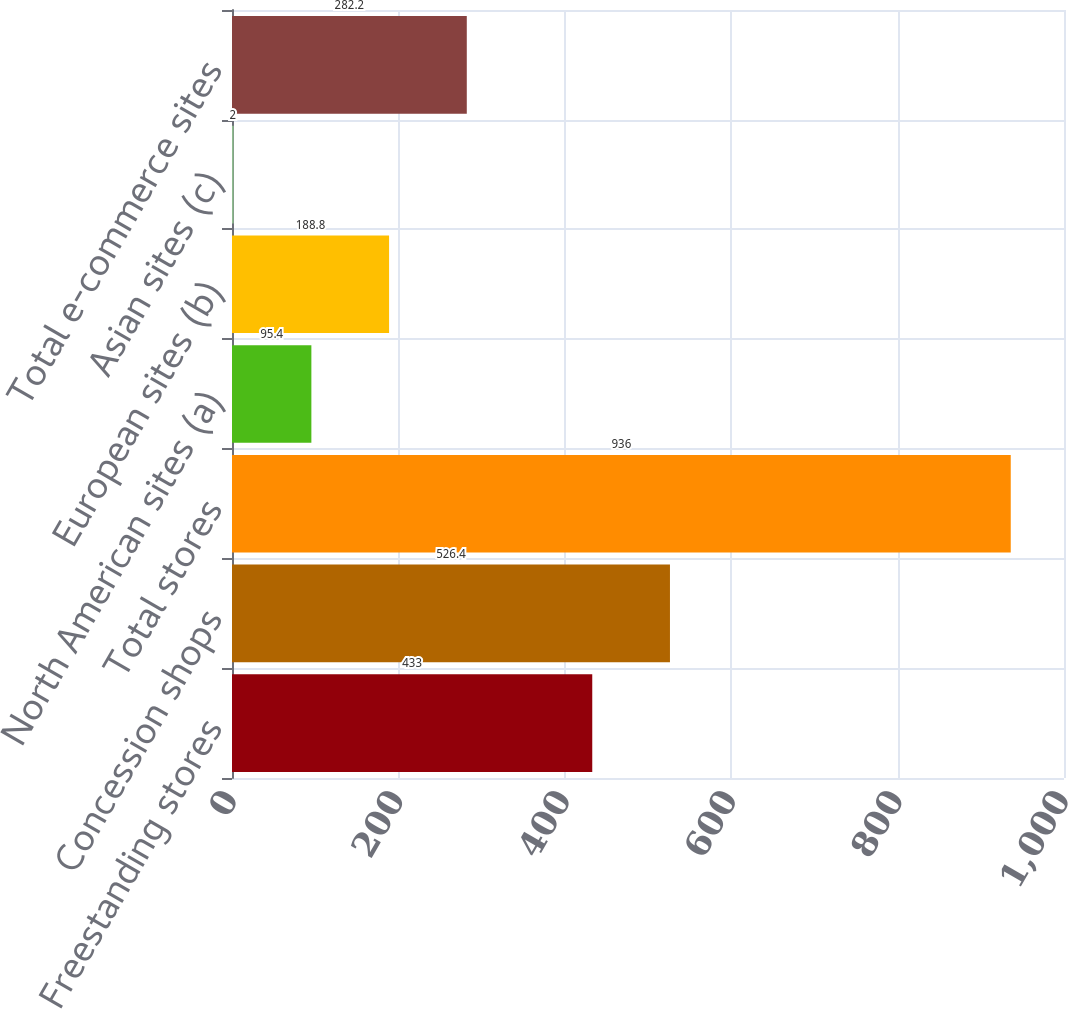Convert chart to OTSL. <chart><loc_0><loc_0><loc_500><loc_500><bar_chart><fcel>Freestanding stores<fcel>Concession shops<fcel>Total stores<fcel>North American sites (a)<fcel>European sites (b)<fcel>Asian sites (c)<fcel>Total e-commerce sites<nl><fcel>433<fcel>526.4<fcel>936<fcel>95.4<fcel>188.8<fcel>2<fcel>282.2<nl></chart> 